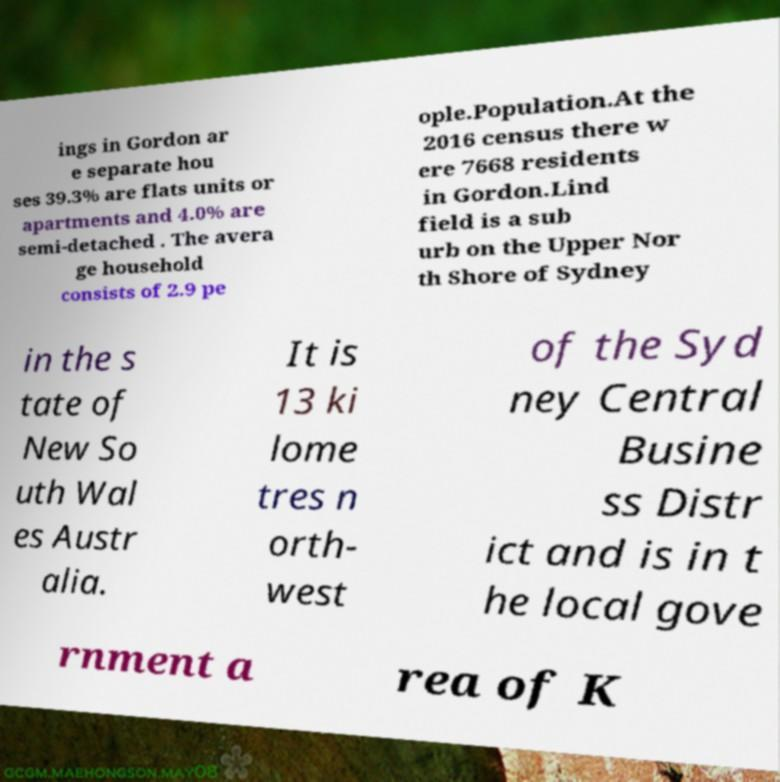Please read and relay the text visible in this image. What does it say? ings in Gordon ar e separate hou ses 39.3% are flats units or apartments and 4.0% are semi-detached . The avera ge household consists of 2.9 pe ople.Population.At the 2016 census there w ere 7668 residents in Gordon.Lind field is a sub urb on the Upper Nor th Shore of Sydney in the s tate of New So uth Wal es Austr alia. It is 13 ki lome tres n orth- west of the Syd ney Central Busine ss Distr ict and is in t he local gove rnment a rea of K 